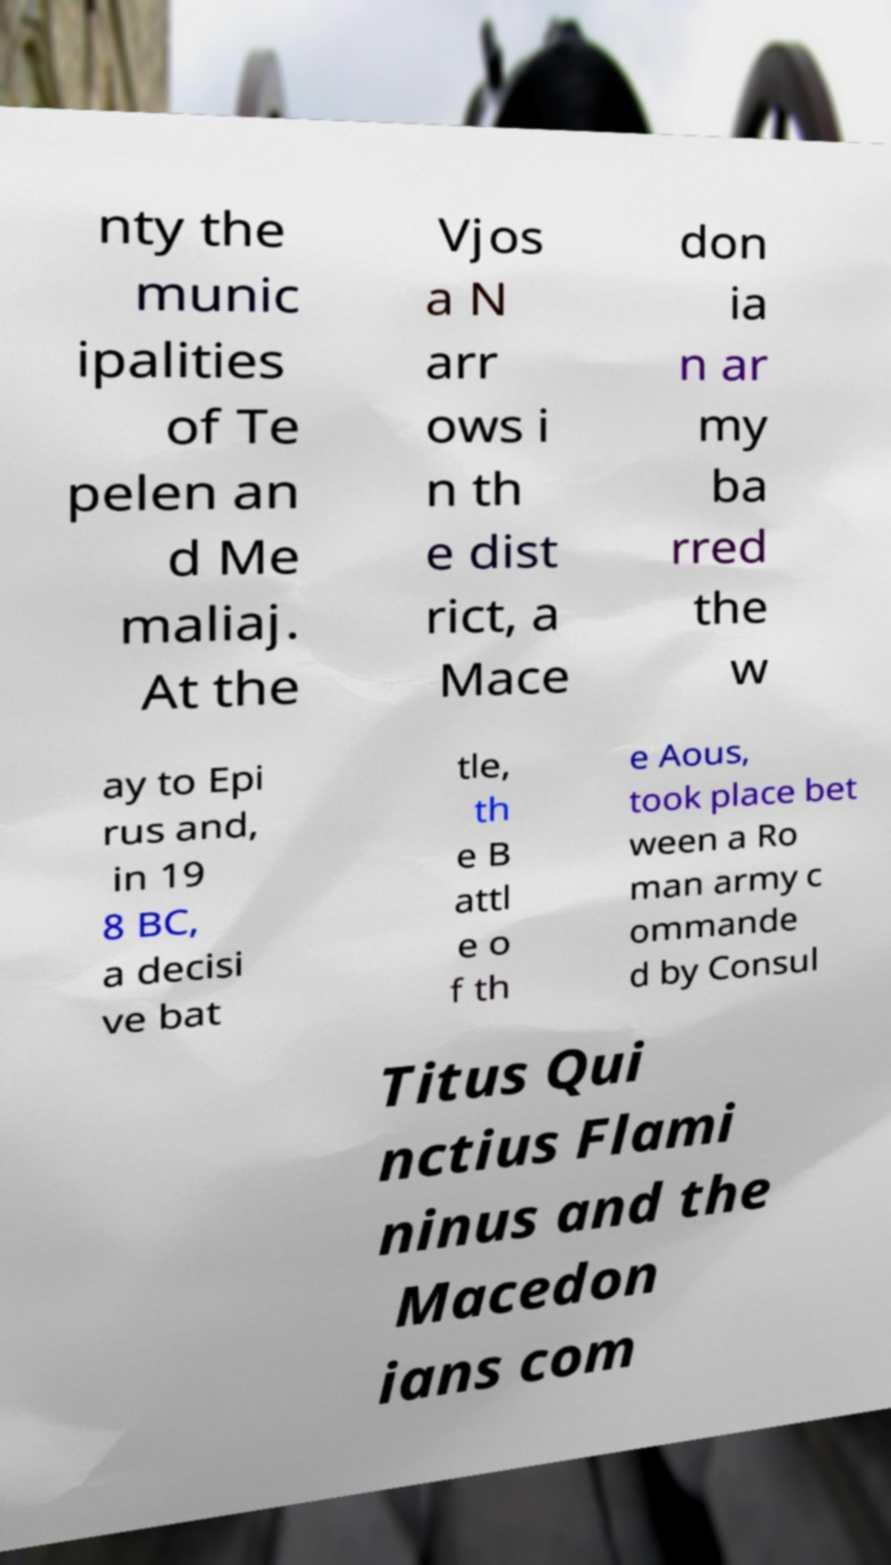Could you extract and type out the text from this image? nty the munic ipalities of Te pelen an d Me maliaj. At the Vjos a N arr ows i n th e dist rict, a Mace don ia n ar my ba rred the w ay to Epi rus and, in 19 8 BC, a decisi ve bat tle, th e B attl e o f th e Aous, took place bet ween a Ro man army c ommande d by Consul Titus Qui nctius Flami ninus and the Macedon ians com 